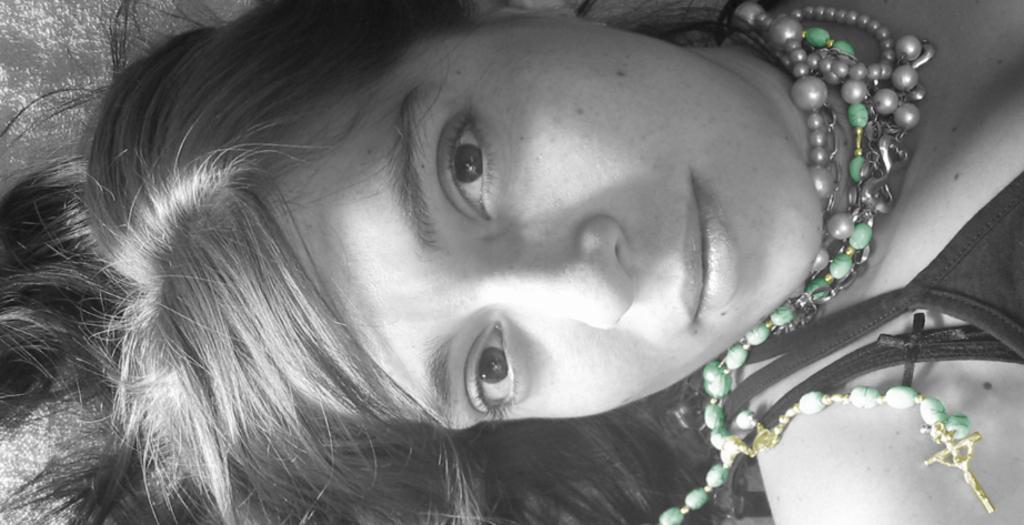Describe this image in one or two sentences. There is a women in a t-shirt, wearing beads necklace, smiling and lying on the bed. The background is white in color. 